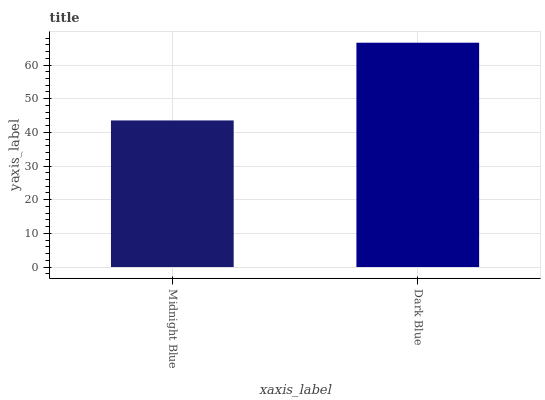Is Dark Blue the minimum?
Answer yes or no. No. Is Dark Blue greater than Midnight Blue?
Answer yes or no. Yes. Is Midnight Blue less than Dark Blue?
Answer yes or no. Yes. Is Midnight Blue greater than Dark Blue?
Answer yes or no. No. Is Dark Blue less than Midnight Blue?
Answer yes or no. No. Is Dark Blue the high median?
Answer yes or no. Yes. Is Midnight Blue the low median?
Answer yes or no. Yes. Is Midnight Blue the high median?
Answer yes or no. No. Is Dark Blue the low median?
Answer yes or no. No. 